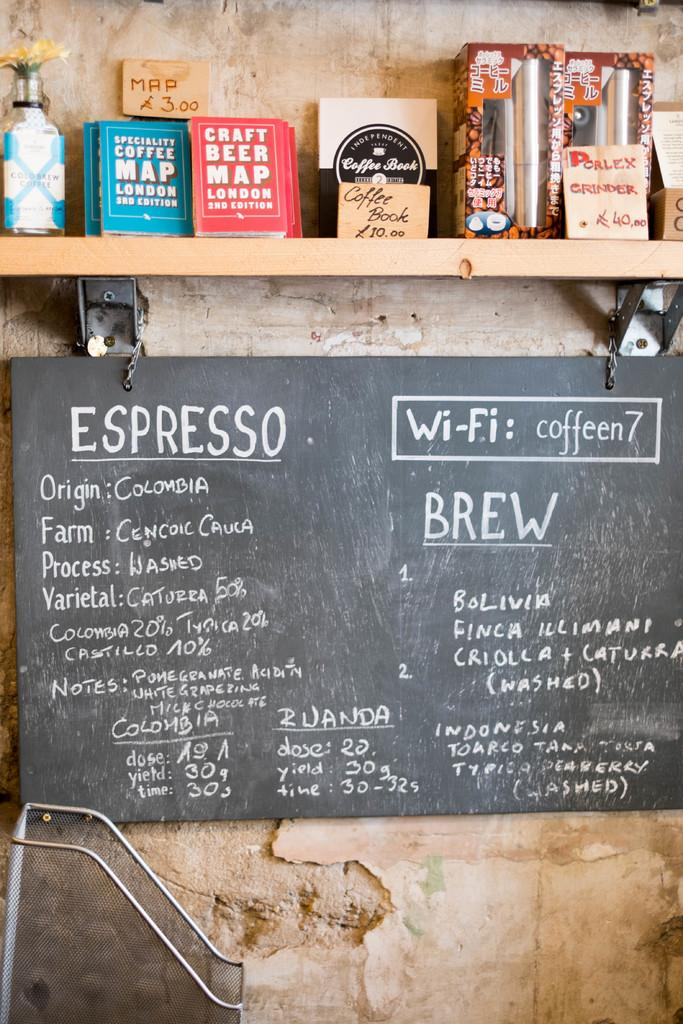<image>
Present a compact description of the photo's key features. A menu featuring the wifi password, which is coffeen7, hangs on the wall. 